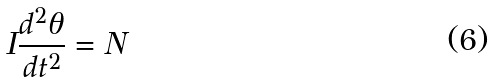<formula> <loc_0><loc_0><loc_500><loc_500>I \frac { d ^ { 2 } \theta } { d t ^ { 2 } } = N</formula> 